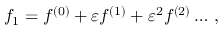<formula> <loc_0><loc_0><loc_500><loc_500>\begin{array} { r } { f _ { 1 } = f ^ { ( 0 ) } + \varepsilon f ^ { ( 1 ) } + \varepsilon ^ { 2 } f ^ { ( 2 ) } \dots \, , } \end{array}</formula> 